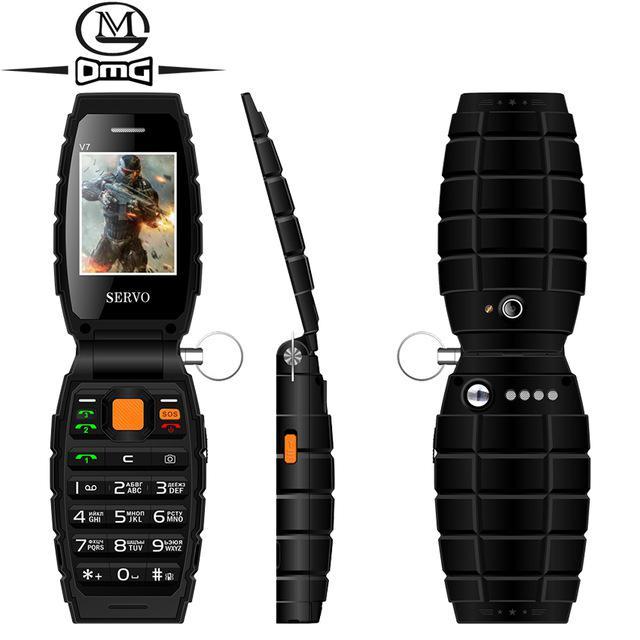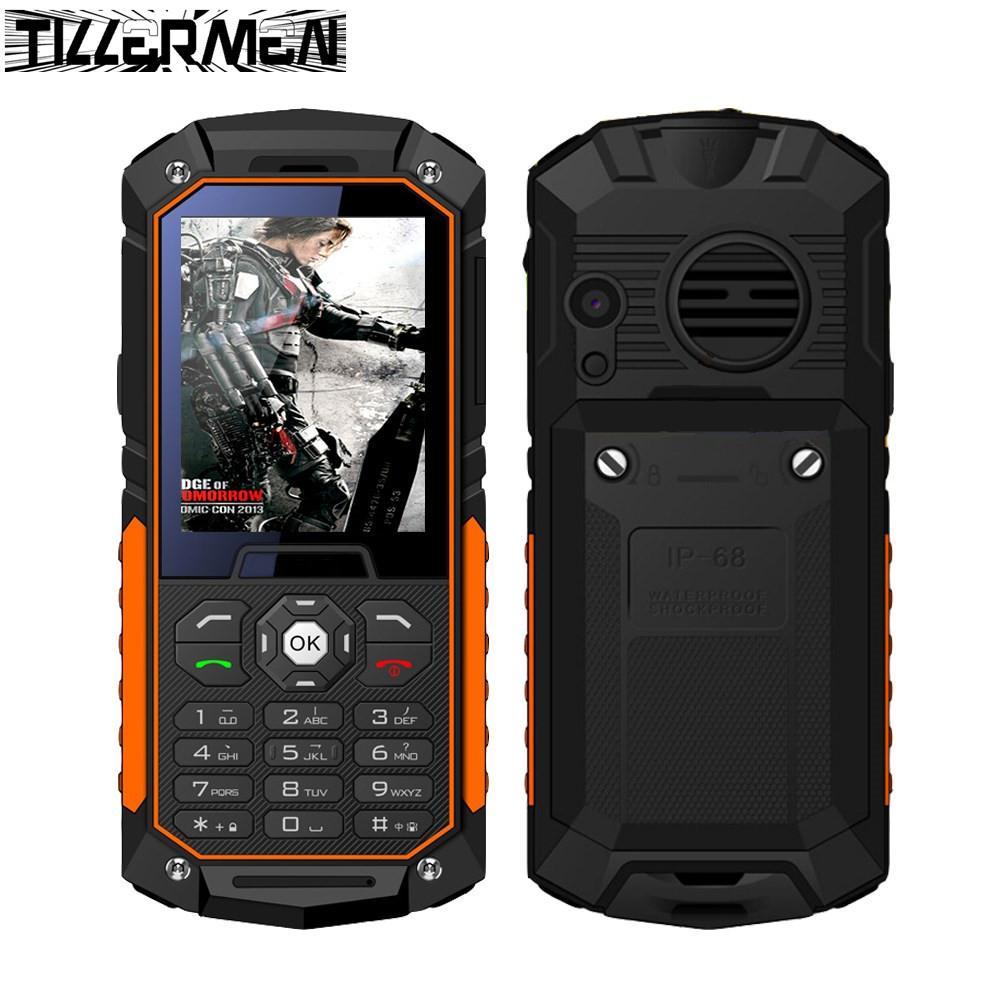The first image is the image on the left, the second image is the image on the right. Considering the images on both sides, is "One of the phones shows an image of four people in a sunset." valid? Answer yes or no. No. The first image is the image on the left, the second image is the image on the right. Assess this claim about the two images: "One image features a grenade-look flip phone with a round 'pin' on its side, and the phone is shown flipped open in at least a forward and a side view.". Correct or not? Answer yes or no. Yes. 